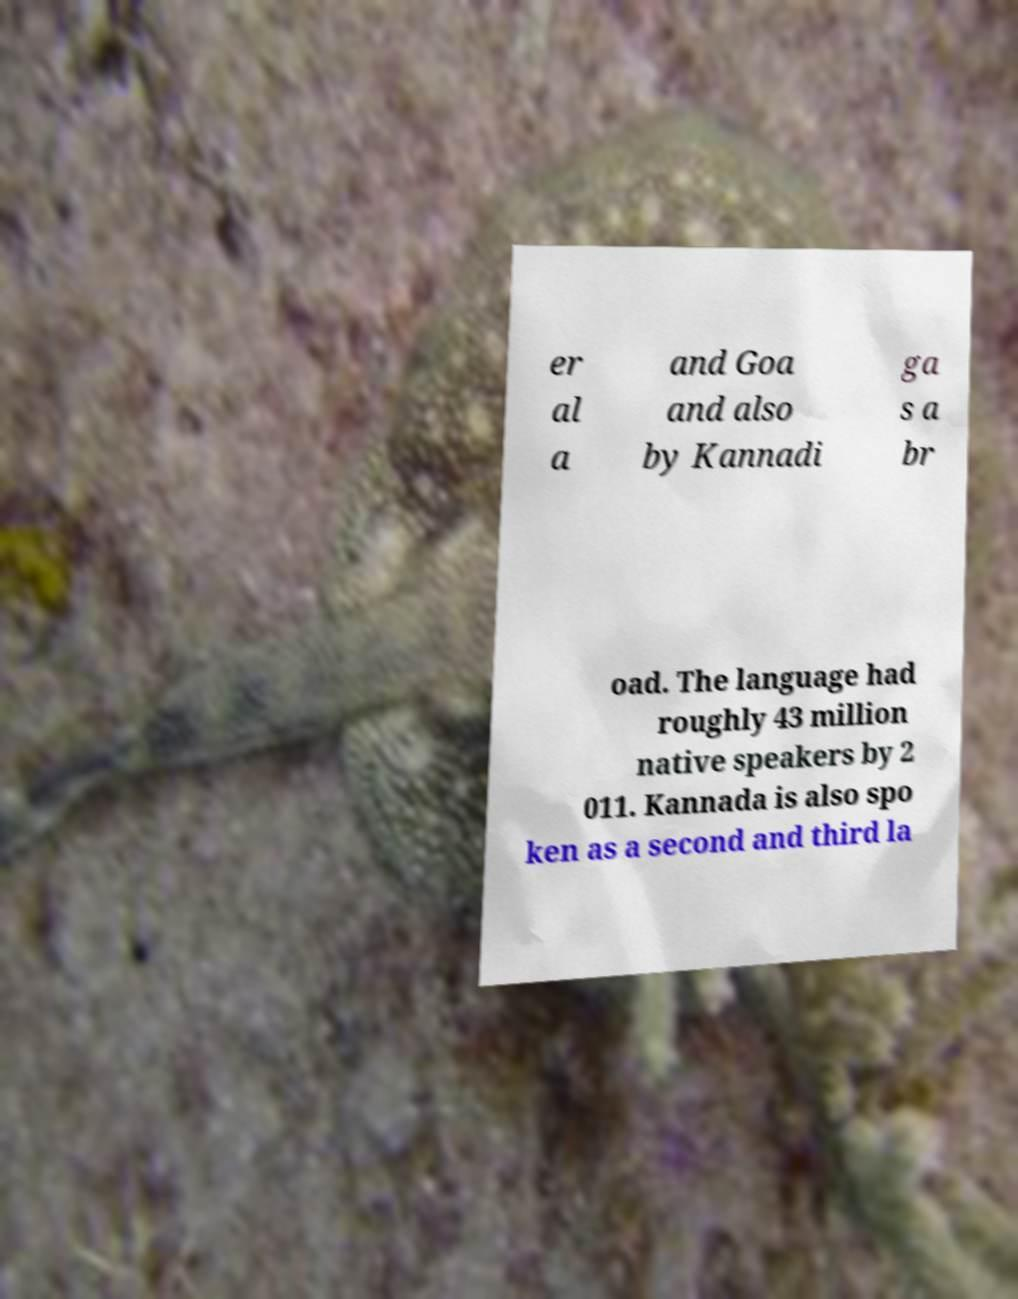Please read and relay the text visible in this image. What does it say? er al a and Goa and also by Kannadi ga s a br oad. The language had roughly 43 million native speakers by 2 011. Kannada is also spo ken as a second and third la 